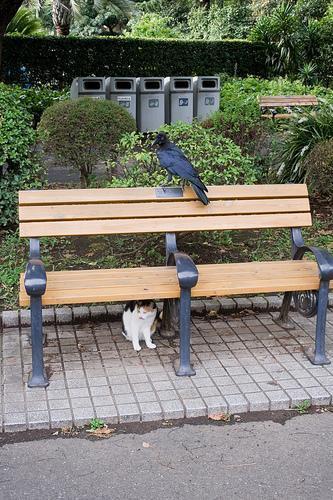How many benches are in the picture?
Give a very brief answer. 2. How many people are sitting on the bench?
Give a very brief answer. 0. How many giraffes are there?
Give a very brief answer. 0. 